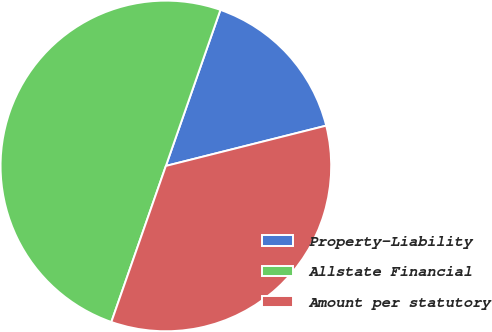<chart> <loc_0><loc_0><loc_500><loc_500><pie_chart><fcel>Property-Liability<fcel>Allstate Financial<fcel>Amount per statutory<nl><fcel>15.73%<fcel>50.0%<fcel>34.27%<nl></chart> 